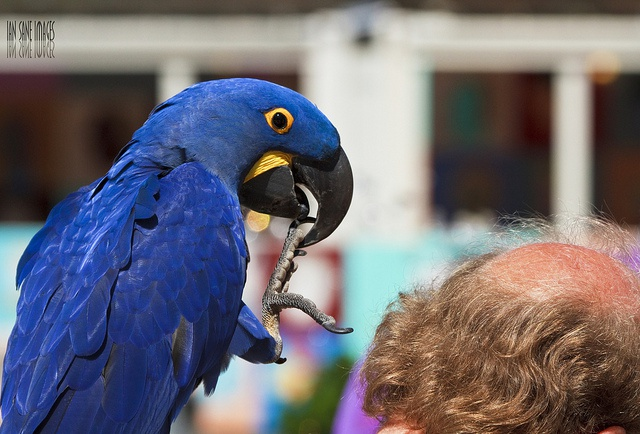Describe the objects in this image and their specific colors. I can see bird in gray, navy, blue, black, and darkblue tones and people in gray, brown, maroon, and tan tones in this image. 